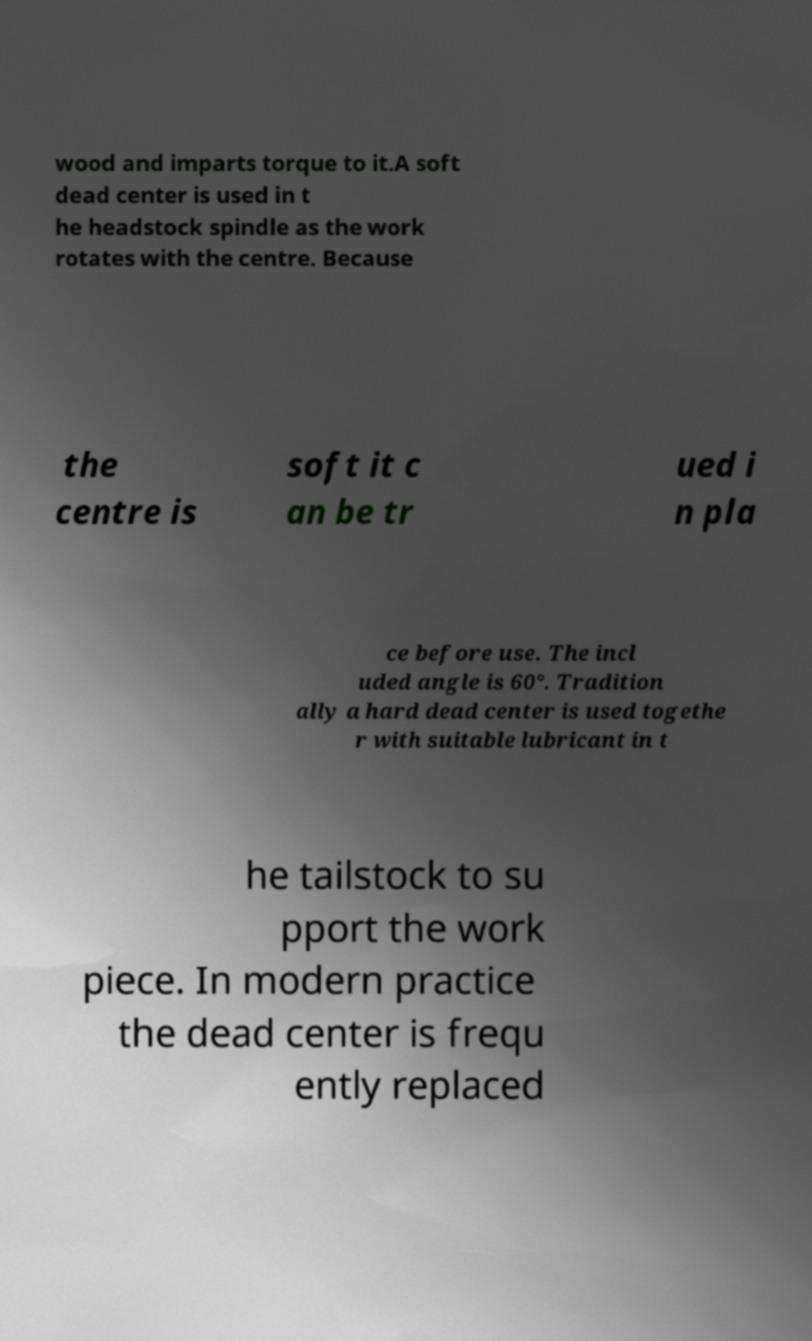For documentation purposes, I need the text within this image transcribed. Could you provide that? wood and imparts torque to it.A soft dead center is used in t he headstock spindle as the work rotates with the centre. Because the centre is soft it c an be tr ued i n pla ce before use. The incl uded angle is 60°. Tradition ally a hard dead center is used togethe r with suitable lubricant in t he tailstock to su pport the work piece. In modern practice the dead center is frequ ently replaced 